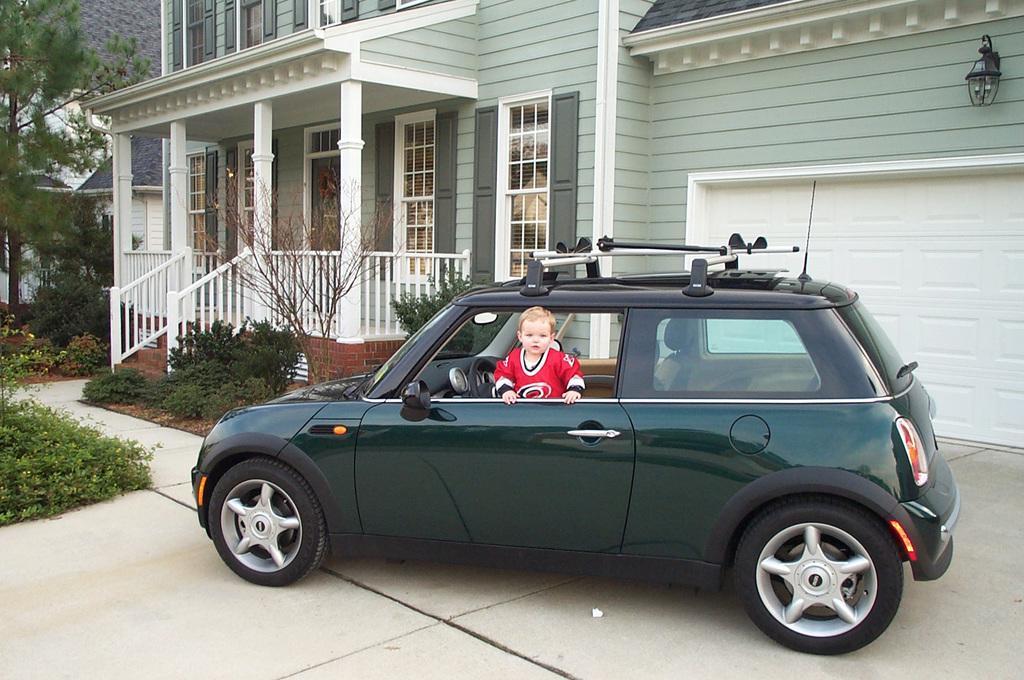How would you summarize this image in a sentence or two? A boy is peeing out of a window of a car parked in front of a house. 